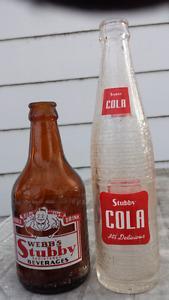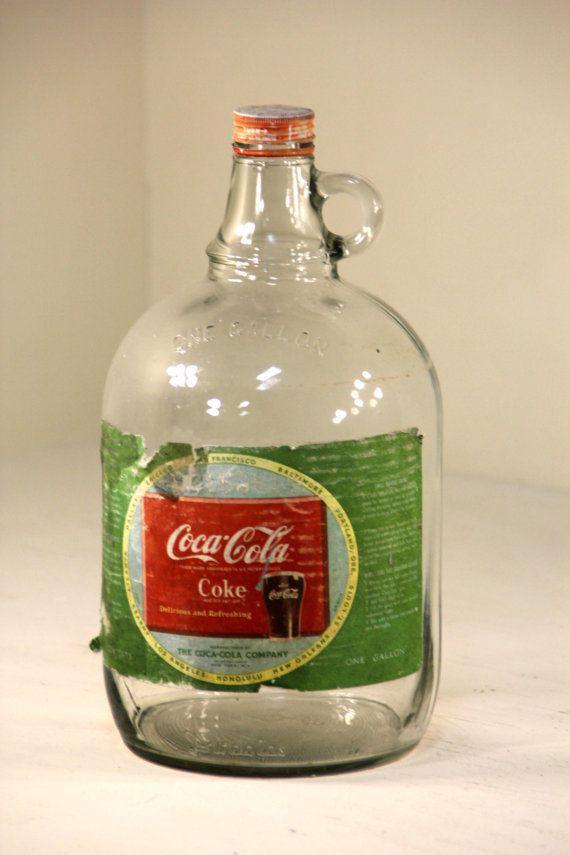The first image is the image on the left, the second image is the image on the right. Examine the images to the left and right. Is the description "The bottle in one of the images could be called a jug." accurate? Answer yes or no. Yes. The first image is the image on the left, the second image is the image on the right. Given the left and right images, does the statement "There is one bottle in each image." hold true? Answer yes or no. No. 